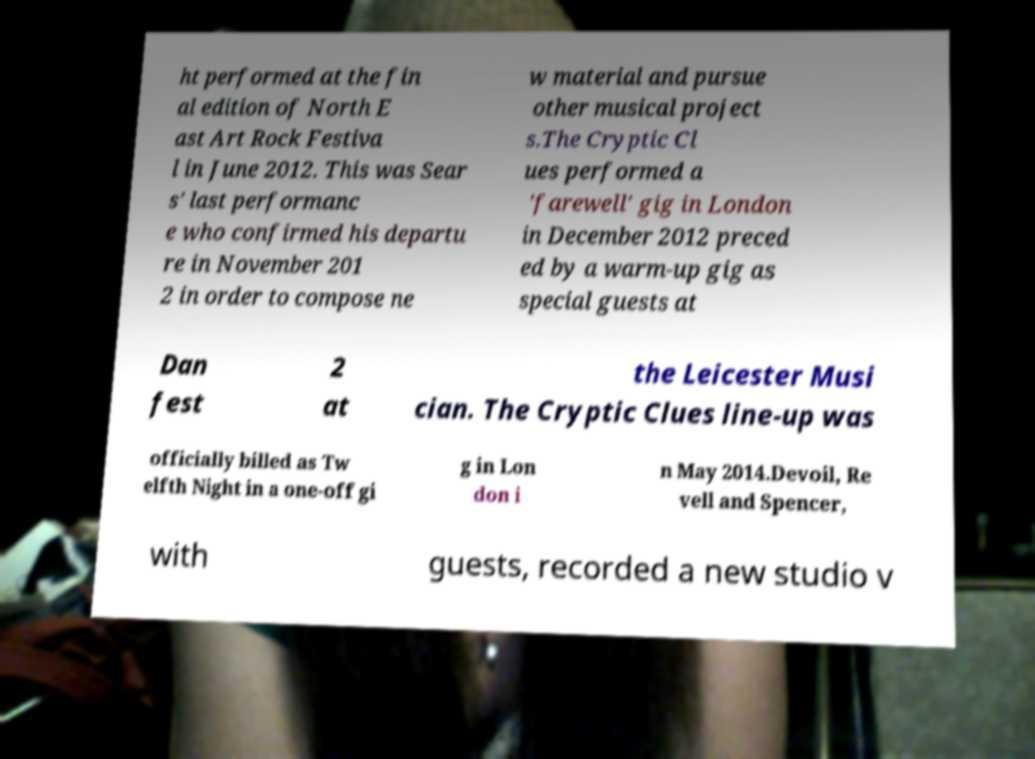Can you read and provide the text displayed in the image?This photo seems to have some interesting text. Can you extract and type it out for me? ht performed at the fin al edition of North E ast Art Rock Festiva l in June 2012. This was Sear s' last performanc e who confirmed his departu re in November 201 2 in order to compose ne w material and pursue other musical project s.The Cryptic Cl ues performed a 'farewell' gig in London in December 2012 preced ed by a warm-up gig as special guests at Dan fest 2 at the Leicester Musi cian. The Cryptic Clues line-up was officially billed as Tw elfth Night in a one-off gi g in Lon don i n May 2014.Devoil, Re vell and Spencer, with guests, recorded a new studio v 